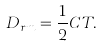Convert formula to latex. <formula><loc_0><loc_0><loc_500><loc_500>D _ { r m } = \frac { 1 } { 2 } C T .</formula> 